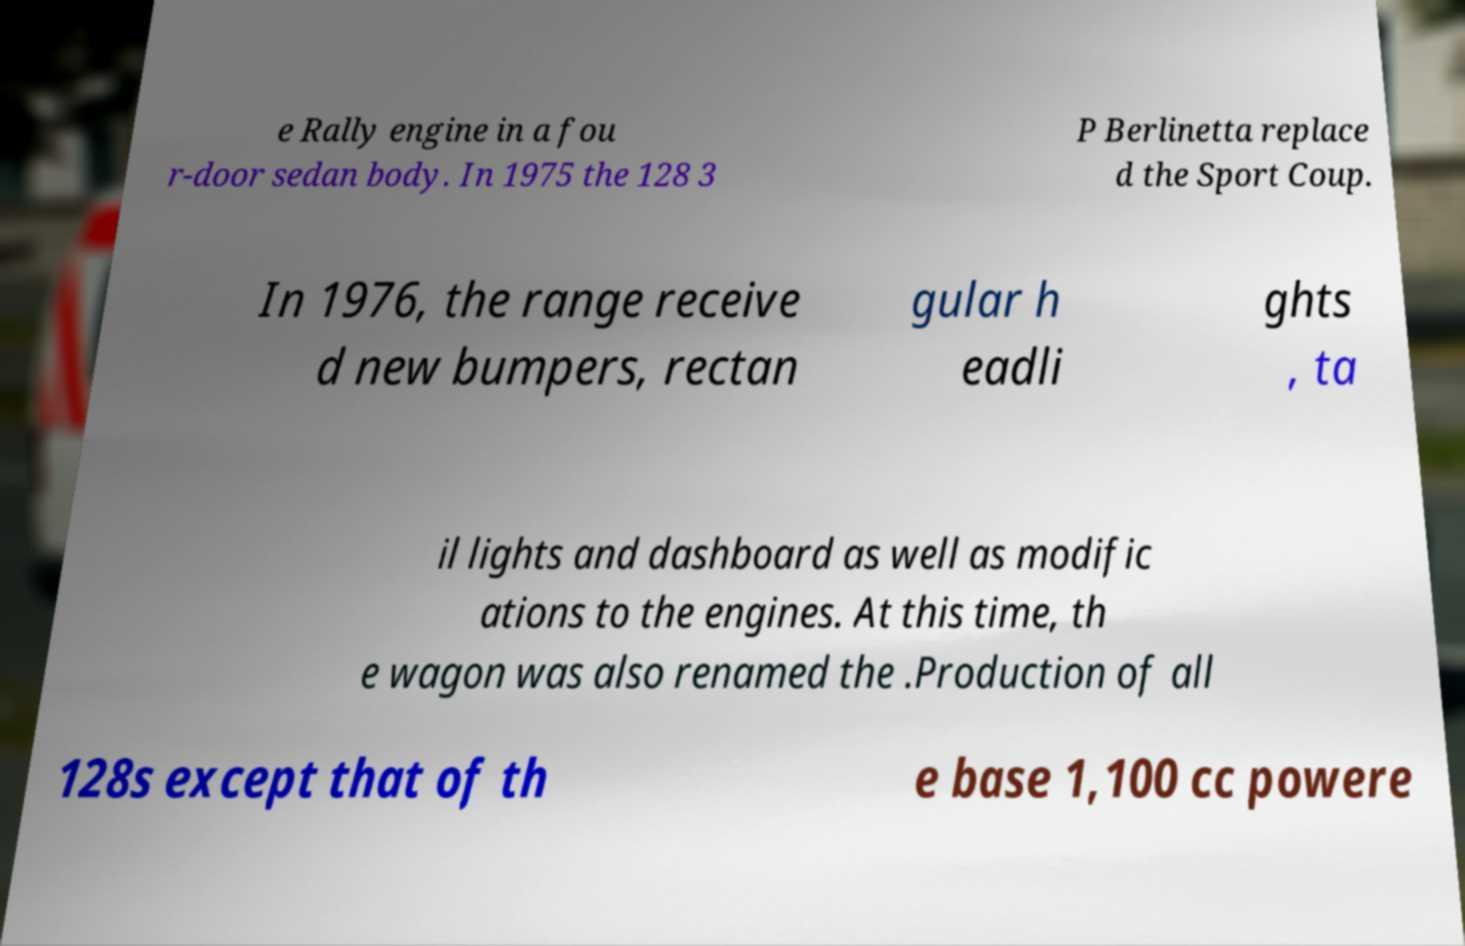There's text embedded in this image that I need extracted. Can you transcribe it verbatim? e Rally engine in a fou r-door sedan body. In 1975 the 128 3 P Berlinetta replace d the Sport Coup. In 1976, the range receive d new bumpers, rectan gular h eadli ghts , ta il lights and dashboard as well as modific ations to the engines. At this time, th e wagon was also renamed the .Production of all 128s except that of th e base 1,100 cc powere 